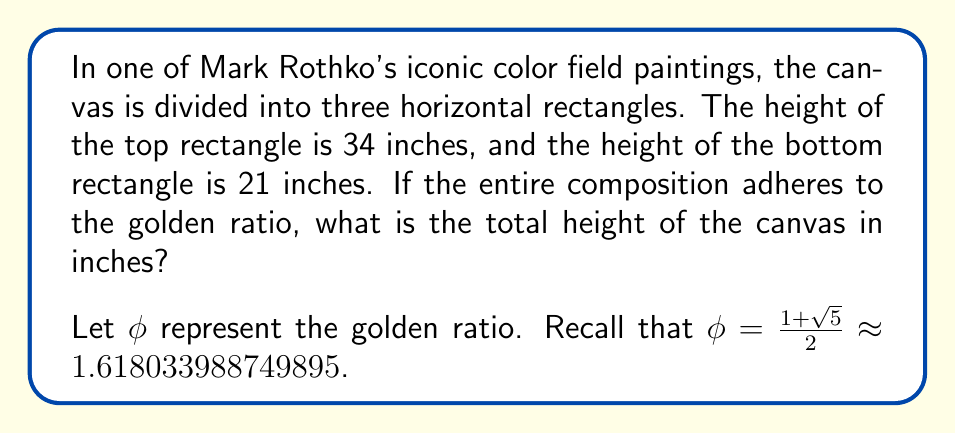Can you solve this math problem? To solve this problem, we'll use the properties of the golden ratio and the given information about Rothko's painting. Let's approach this step-by-step:

1) In a composition following the golden ratio, the ratio of the whole to the larger part is equal to the ratio of the larger part to the smaller part.

2) Let's denote the heights as follows:
   - Top rectangle: $a = 34$ inches
   - Middle rectangle: $b$ inches (unknown)
   - Bottom rectangle: $c = 21$ inches
   - Total height: $h$ inches (what we're solving for)

3) According to the golden ratio property:

   $$\frac{h}{h-c} = \frac{h-c}{c} = \phi$$

4) We can write this as an equation:

   $$\frac{h}{h-21} = \phi$$

5) Cross multiply:

   $$h = \phi(h-21)$$

6) Expand:

   $$h = \phi h - 21\phi$$

7) Subtract $\phi h$ from both sides:

   $$h - \phi h = -21\phi$$
   $$(1-\phi)h = -21\phi$$

8) Divide both sides by $(1-\phi)$:

   $$h = \frac{21\phi}{(\phi-1)}$$

9) We know that $\phi^2 = \phi + 1$, so $\phi - 1 = \frac{1}{\phi}$

10) Substitute this in:

    $$h = 21\phi^2 = 21(\phi + 1) = 21\phi + 21$$

11) Now, substitute the value of $\phi$:

    $$h = 21(\frac{1 + \sqrt{5}}{2}) + 21 = \frac{21(1 + \sqrt{5})}{2} + 21 = \frac{21(1 + \sqrt{5} + 2)}{2} = \frac{21(3 + \sqrt{5})}{2}$$

12) Calculate the final value:

    $$h = \frac{21(3 + \sqrt{5})}{2} \approx 55$$

Therefore, the total height of the canvas is approximately 55 inches.
Answer: The total height of the canvas is $\frac{21(3 + \sqrt{5})}{2} \approx 55$ inches. 